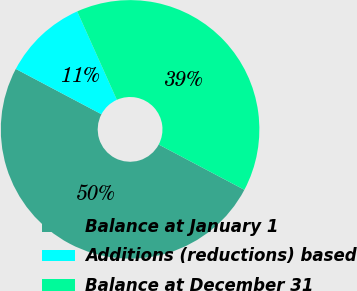Convert chart to OTSL. <chart><loc_0><loc_0><loc_500><loc_500><pie_chart><fcel>Balance at January 1<fcel>Additions (reductions) based<fcel>Balance at December 31<nl><fcel>50.0%<fcel>10.55%<fcel>39.45%<nl></chart> 